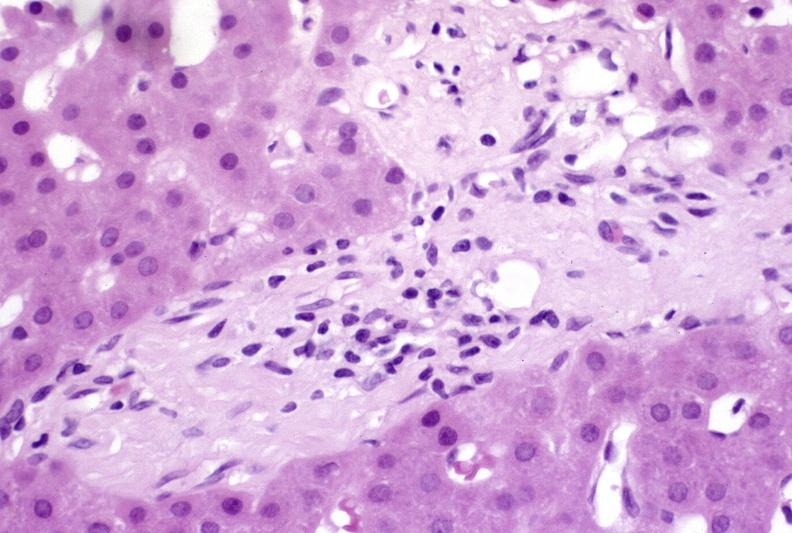s gross photo of tumor in this file present?
Answer the question using a single word or phrase. No 